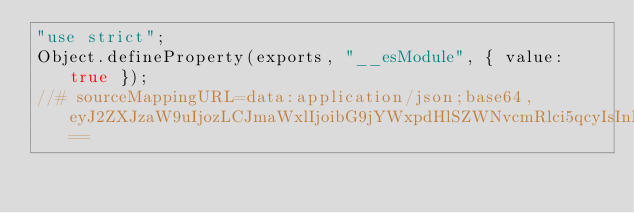<code> <loc_0><loc_0><loc_500><loc_500><_JavaScript_>"use strict";
Object.defineProperty(exports, "__esModule", { value: true });
//# sourceMappingURL=data:application/json;base64,eyJ2ZXJzaW9uIjozLCJmaWxlIjoibG9jYWxpdHlSZWNvcmRlci5qcyIsInNvdXJjZVJvb3QiOiIiLCJzb3VyY2VzIjpbIi4uLy4uLy4uLy4uL3NyYy8wMS1yZWNvcmRpbmcvMDEtbG9jYWxpdGllcy8wMWEtbG9jYWxpdGllcy9sb2NhbGl0eVJlY29yZGVyLnRzIl0sIm5hbWVzIjpbXSwibWFwcGluZ3MiOiIifQ==</code> 